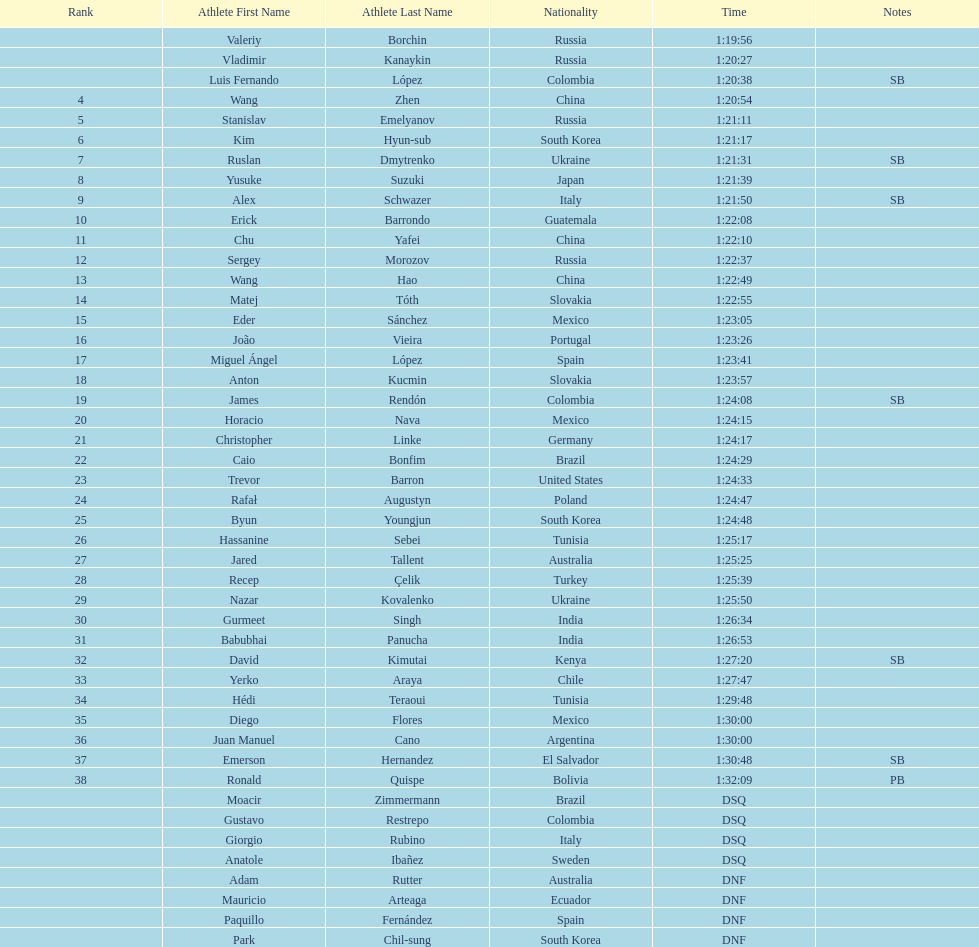Which athlete is the only american to be ranked in the 20km? Trevor Barron. 